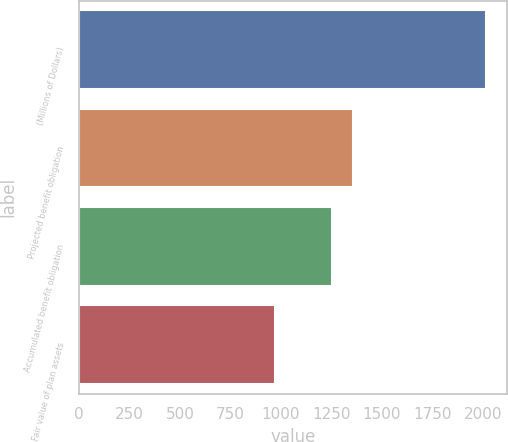<chart> <loc_0><loc_0><loc_500><loc_500><bar_chart><fcel>(Millions of Dollars)<fcel>Projected benefit obligation<fcel>Accumulated benefit obligation<fcel>Fair value of plan assets<nl><fcel>2018<fcel>1357.53<fcel>1252.7<fcel>969.7<nl></chart> 